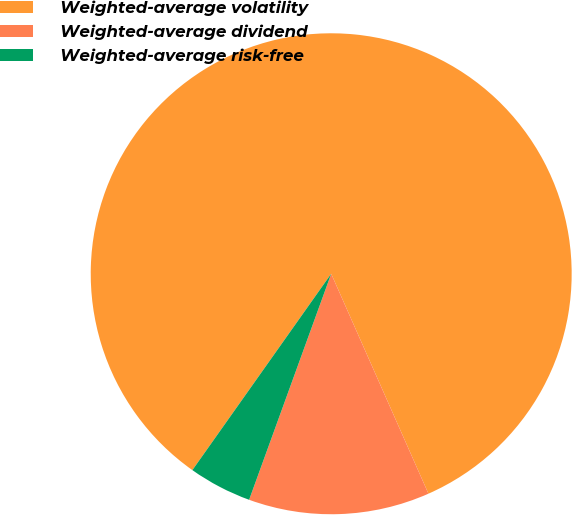Convert chart. <chart><loc_0><loc_0><loc_500><loc_500><pie_chart><fcel>Weighted-average volatility<fcel>Weighted-average dividend<fcel>Weighted-average risk-free<nl><fcel>83.58%<fcel>12.17%<fcel>4.25%<nl></chart> 